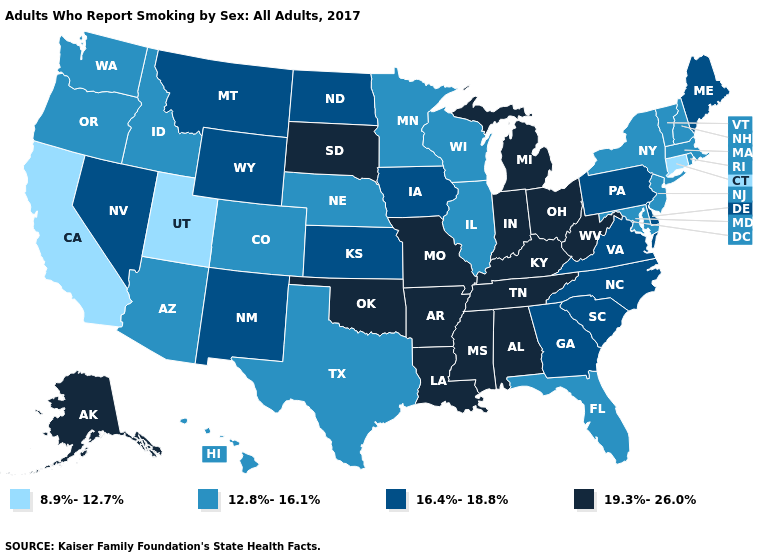Does Rhode Island have the lowest value in the USA?
Write a very short answer. No. Which states have the lowest value in the Northeast?
Be succinct. Connecticut. Does Idaho have the same value as Montana?
Short answer required. No. Name the states that have a value in the range 16.4%-18.8%?
Concise answer only. Delaware, Georgia, Iowa, Kansas, Maine, Montana, Nevada, New Mexico, North Carolina, North Dakota, Pennsylvania, South Carolina, Virginia, Wyoming. Does Utah have a higher value than Washington?
Give a very brief answer. No. What is the lowest value in the USA?
Concise answer only. 8.9%-12.7%. What is the highest value in states that border Vermont?
Quick response, please. 12.8%-16.1%. What is the value of Arkansas?
Concise answer only. 19.3%-26.0%. Does North Dakota have the same value as Florida?
Keep it brief. No. How many symbols are there in the legend?
Short answer required. 4. Among the states that border Colorado , which have the highest value?
Be succinct. Oklahoma. What is the value of Alabama?
Write a very short answer. 19.3%-26.0%. What is the highest value in states that border North Dakota?
Write a very short answer. 19.3%-26.0%. What is the highest value in the MidWest ?
Write a very short answer. 19.3%-26.0%. Among the states that border Kentucky , does Illinois have the lowest value?
Write a very short answer. Yes. 